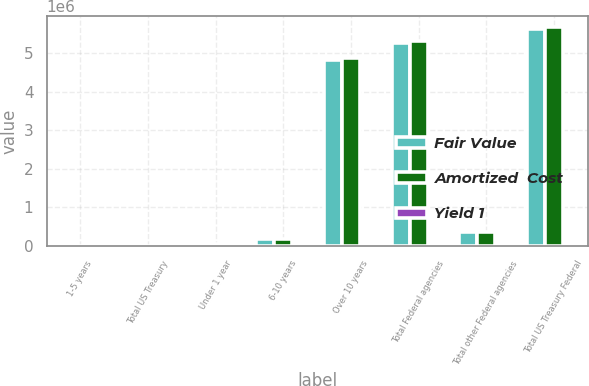Convert chart. <chart><loc_0><loc_0><loc_500><loc_500><stacked_bar_chart><ecel><fcel>1-5 years<fcel>Total US Treasury<fcel>Under 1 year<fcel>6-10 years<fcel>Over 10 years<fcel>Total Federal agencies<fcel>Total other Federal agencies<fcel>Total US Treasury Federal<nl><fcel>Fair Value<fcel>5435<fcel>5435<fcel>47023<fcel>184576<fcel>4.82552e+06<fcel>5.2739e+06<fcel>349715<fcel>5.62905e+06<nl><fcel>Amortized  Cost<fcel>5452<fcel>5452<fcel>47190<fcel>186938<fcel>4.8675e+06<fcel>5.3227e+06<fcel>351543<fcel>5.6797e+06<nl><fcel>Yield 1<fcel>1.2<fcel>1.2<fcel>1.99<fcel>2.87<fcel>2.42<fcel>2.43<fcel>2.51<fcel>2.43<nl></chart> 